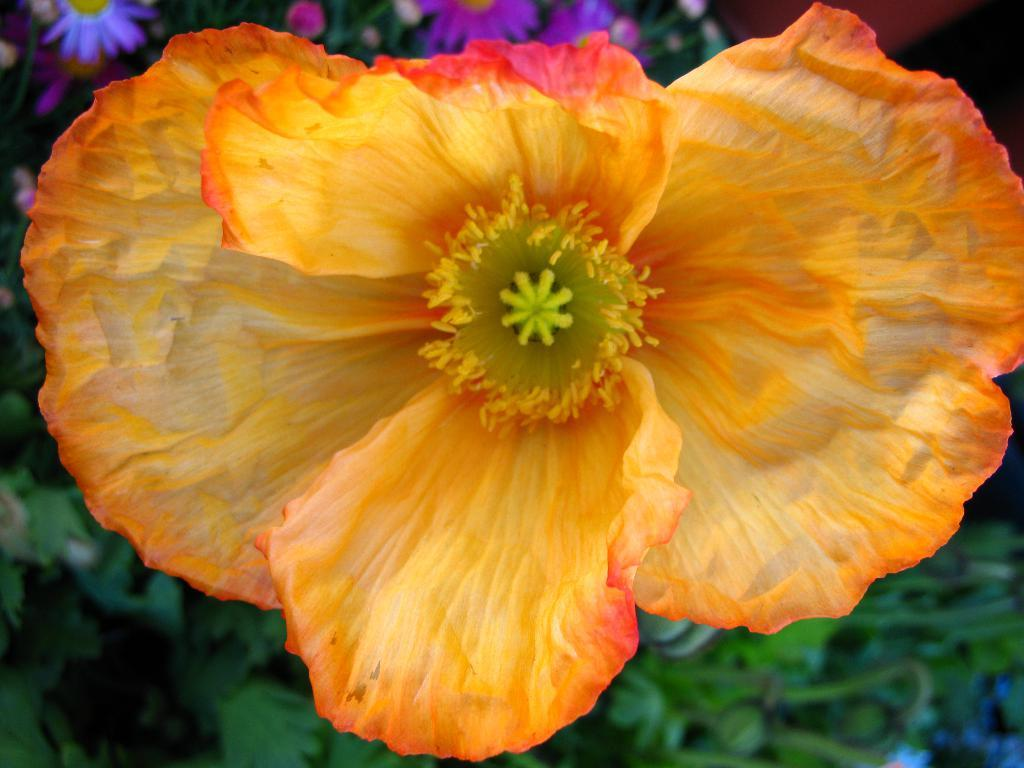What is the main subject of the image? There is a flower present in the image. What can be seen in the background of the image? There are plants and flowers in the background of the image. What type of crack is visible in the image? There is no crack present in the image. What date is marked on the calendar in the image? There is no calendar present in the image. 